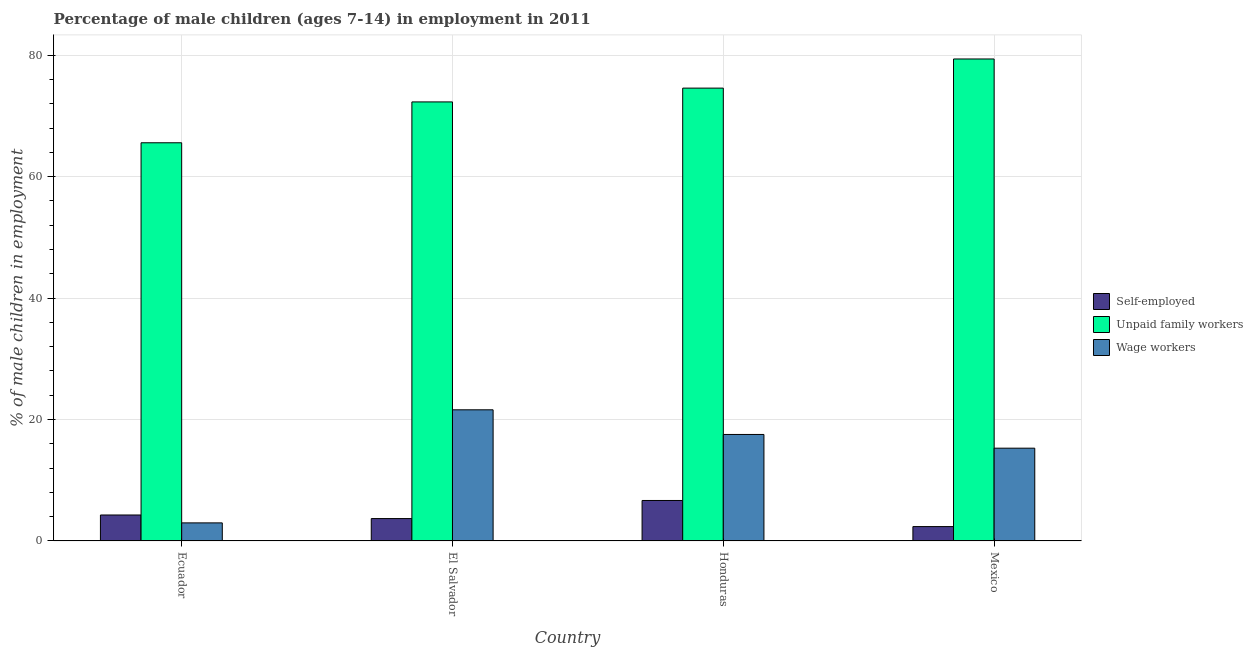How many different coloured bars are there?
Your response must be concise. 3. How many groups of bars are there?
Provide a succinct answer. 4. How many bars are there on the 1st tick from the right?
Ensure brevity in your answer.  3. What is the label of the 2nd group of bars from the left?
Ensure brevity in your answer.  El Salvador. What is the percentage of children employed as unpaid family workers in El Salvador?
Keep it short and to the point. 72.3. Across all countries, what is the maximum percentage of children employed as wage workers?
Your answer should be very brief. 21.6. Across all countries, what is the minimum percentage of children employed as wage workers?
Offer a very short reply. 2.98. What is the total percentage of children employed as unpaid family workers in the graph?
Provide a short and direct response. 291.81. What is the difference between the percentage of self employed children in El Salvador and that in Honduras?
Ensure brevity in your answer.  -2.98. What is the difference between the percentage of children employed as unpaid family workers in Ecuador and the percentage of children employed as wage workers in El Salvador?
Provide a succinct answer. 43.97. What is the average percentage of self employed children per country?
Your answer should be compact. 4.25. What is the difference between the percentage of children employed as wage workers and percentage of children employed as unpaid family workers in Ecuador?
Your answer should be very brief. -62.59. What is the ratio of the percentage of self employed children in El Salvador to that in Honduras?
Provide a succinct answer. 0.55. Is the percentage of children employed as unpaid family workers in Ecuador less than that in Honduras?
Provide a short and direct response. Yes. What is the difference between the highest and the second highest percentage of self employed children?
Ensure brevity in your answer.  2.39. What is the difference between the highest and the lowest percentage of self employed children?
Offer a terse response. 4.3. In how many countries, is the percentage of self employed children greater than the average percentage of self employed children taken over all countries?
Provide a short and direct response. 2. Is the sum of the percentage of children employed as wage workers in Honduras and Mexico greater than the maximum percentage of children employed as unpaid family workers across all countries?
Keep it short and to the point. No. What does the 3rd bar from the left in Mexico represents?
Offer a terse response. Wage workers. What does the 2nd bar from the right in Ecuador represents?
Give a very brief answer. Unpaid family workers. How many countries are there in the graph?
Your answer should be very brief. 4. What is the difference between two consecutive major ticks on the Y-axis?
Offer a very short reply. 20. Are the values on the major ticks of Y-axis written in scientific E-notation?
Offer a very short reply. No. Does the graph contain any zero values?
Make the answer very short. No. Does the graph contain grids?
Your answer should be compact. Yes. How many legend labels are there?
Your response must be concise. 3. How are the legend labels stacked?
Keep it short and to the point. Vertical. What is the title of the graph?
Your answer should be very brief. Percentage of male children (ages 7-14) in employment in 2011. What is the label or title of the Y-axis?
Give a very brief answer. % of male children in employment. What is the % of male children in employment of Self-employed in Ecuador?
Your answer should be very brief. 4.28. What is the % of male children in employment in Unpaid family workers in Ecuador?
Provide a short and direct response. 65.57. What is the % of male children in employment in Wage workers in Ecuador?
Offer a very short reply. 2.98. What is the % of male children in employment of Self-employed in El Salvador?
Your answer should be very brief. 3.69. What is the % of male children in employment of Unpaid family workers in El Salvador?
Your answer should be compact. 72.3. What is the % of male children in employment in Wage workers in El Salvador?
Ensure brevity in your answer.  21.6. What is the % of male children in employment in Self-employed in Honduras?
Ensure brevity in your answer.  6.67. What is the % of male children in employment in Unpaid family workers in Honduras?
Give a very brief answer. 74.57. What is the % of male children in employment in Wage workers in Honduras?
Your response must be concise. 17.54. What is the % of male children in employment of Self-employed in Mexico?
Your response must be concise. 2.37. What is the % of male children in employment in Unpaid family workers in Mexico?
Give a very brief answer. 79.37. What is the % of male children in employment of Wage workers in Mexico?
Make the answer very short. 15.28. Across all countries, what is the maximum % of male children in employment in Self-employed?
Ensure brevity in your answer.  6.67. Across all countries, what is the maximum % of male children in employment in Unpaid family workers?
Your answer should be compact. 79.37. Across all countries, what is the maximum % of male children in employment of Wage workers?
Ensure brevity in your answer.  21.6. Across all countries, what is the minimum % of male children in employment of Self-employed?
Offer a very short reply. 2.37. Across all countries, what is the minimum % of male children in employment of Unpaid family workers?
Your answer should be very brief. 65.57. Across all countries, what is the minimum % of male children in employment in Wage workers?
Your response must be concise. 2.98. What is the total % of male children in employment in Self-employed in the graph?
Keep it short and to the point. 17.01. What is the total % of male children in employment in Unpaid family workers in the graph?
Provide a succinct answer. 291.81. What is the total % of male children in employment in Wage workers in the graph?
Offer a terse response. 57.4. What is the difference between the % of male children in employment of Self-employed in Ecuador and that in El Salvador?
Provide a short and direct response. 0.59. What is the difference between the % of male children in employment of Unpaid family workers in Ecuador and that in El Salvador?
Offer a very short reply. -6.73. What is the difference between the % of male children in employment in Wage workers in Ecuador and that in El Salvador?
Your answer should be compact. -18.62. What is the difference between the % of male children in employment of Self-employed in Ecuador and that in Honduras?
Provide a succinct answer. -2.39. What is the difference between the % of male children in employment in Wage workers in Ecuador and that in Honduras?
Offer a very short reply. -14.56. What is the difference between the % of male children in employment of Self-employed in Ecuador and that in Mexico?
Keep it short and to the point. 1.91. What is the difference between the % of male children in employment in Wage workers in Ecuador and that in Mexico?
Make the answer very short. -12.3. What is the difference between the % of male children in employment of Self-employed in El Salvador and that in Honduras?
Keep it short and to the point. -2.98. What is the difference between the % of male children in employment in Unpaid family workers in El Salvador and that in Honduras?
Provide a succinct answer. -2.27. What is the difference between the % of male children in employment in Wage workers in El Salvador and that in Honduras?
Provide a succinct answer. 4.06. What is the difference between the % of male children in employment in Self-employed in El Salvador and that in Mexico?
Give a very brief answer. 1.32. What is the difference between the % of male children in employment in Unpaid family workers in El Salvador and that in Mexico?
Keep it short and to the point. -7.07. What is the difference between the % of male children in employment in Wage workers in El Salvador and that in Mexico?
Provide a succinct answer. 6.32. What is the difference between the % of male children in employment in Wage workers in Honduras and that in Mexico?
Provide a succinct answer. 2.26. What is the difference between the % of male children in employment of Self-employed in Ecuador and the % of male children in employment of Unpaid family workers in El Salvador?
Make the answer very short. -68.02. What is the difference between the % of male children in employment in Self-employed in Ecuador and the % of male children in employment in Wage workers in El Salvador?
Make the answer very short. -17.32. What is the difference between the % of male children in employment in Unpaid family workers in Ecuador and the % of male children in employment in Wage workers in El Salvador?
Make the answer very short. 43.97. What is the difference between the % of male children in employment in Self-employed in Ecuador and the % of male children in employment in Unpaid family workers in Honduras?
Your answer should be very brief. -70.29. What is the difference between the % of male children in employment in Self-employed in Ecuador and the % of male children in employment in Wage workers in Honduras?
Make the answer very short. -13.26. What is the difference between the % of male children in employment of Unpaid family workers in Ecuador and the % of male children in employment of Wage workers in Honduras?
Ensure brevity in your answer.  48.03. What is the difference between the % of male children in employment in Self-employed in Ecuador and the % of male children in employment in Unpaid family workers in Mexico?
Offer a terse response. -75.09. What is the difference between the % of male children in employment in Self-employed in Ecuador and the % of male children in employment in Wage workers in Mexico?
Offer a terse response. -11. What is the difference between the % of male children in employment in Unpaid family workers in Ecuador and the % of male children in employment in Wage workers in Mexico?
Offer a very short reply. 50.29. What is the difference between the % of male children in employment in Self-employed in El Salvador and the % of male children in employment in Unpaid family workers in Honduras?
Keep it short and to the point. -70.88. What is the difference between the % of male children in employment in Self-employed in El Salvador and the % of male children in employment in Wage workers in Honduras?
Your answer should be compact. -13.85. What is the difference between the % of male children in employment of Unpaid family workers in El Salvador and the % of male children in employment of Wage workers in Honduras?
Keep it short and to the point. 54.76. What is the difference between the % of male children in employment in Self-employed in El Salvador and the % of male children in employment in Unpaid family workers in Mexico?
Your response must be concise. -75.68. What is the difference between the % of male children in employment in Self-employed in El Salvador and the % of male children in employment in Wage workers in Mexico?
Offer a very short reply. -11.59. What is the difference between the % of male children in employment of Unpaid family workers in El Salvador and the % of male children in employment of Wage workers in Mexico?
Make the answer very short. 57.02. What is the difference between the % of male children in employment in Self-employed in Honduras and the % of male children in employment in Unpaid family workers in Mexico?
Provide a short and direct response. -72.7. What is the difference between the % of male children in employment of Self-employed in Honduras and the % of male children in employment of Wage workers in Mexico?
Your answer should be compact. -8.61. What is the difference between the % of male children in employment in Unpaid family workers in Honduras and the % of male children in employment in Wage workers in Mexico?
Offer a very short reply. 59.29. What is the average % of male children in employment in Self-employed per country?
Your response must be concise. 4.25. What is the average % of male children in employment in Unpaid family workers per country?
Ensure brevity in your answer.  72.95. What is the average % of male children in employment of Wage workers per country?
Offer a terse response. 14.35. What is the difference between the % of male children in employment in Self-employed and % of male children in employment in Unpaid family workers in Ecuador?
Provide a short and direct response. -61.29. What is the difference between the % of male children in employment in Self-employed and % of male children in employment in Wage workers in Ecuador?
Make the answer very short. 1.3. What is the difference between the % of male children in employment of Unpaid family workers and % of male children in employment of Wage workers in Ecuador?
Your answer should be very brief. 62.59. What is the difference between the % of male children in employment in Self-employed and % of male children in employment in Unpaid family workers in El Salvador?
Offer a very short reply. -68.61. What is the difference between the % of male children in employment of Self-employed and % of male children in employment of Wage workers in El Salvador?
Ensure brevity in your answer.  -17.91. What is the difference between the % of male children in employment in Unpaid family workers and % of male children in employment in Wage workers in El Salvador?
Offer a very short reply. 50.7. What is the difference between the % of male children in employment of Self-employed and % of male children in employment of Unpaid family workers in Honduras?
Your response must be concise. -67.9. What is the difference between the % of male children in employment of Self-employed and % of male children in employment of Wage workers in Honduras?
Your response must be concise. -10.87. What is the difference between the % of male children in employment of Unpaid family workers and % of male children in employment of Wage workers in Honduras?
Keep it short and to the point. 57.03. What is the difference between the % of male children in employment of Self-employed and % of male children in employment of Unpaid family workers in Mexico?
Offer a very short reply. -77. What is the difference between the % of male children in employment in Self-employed and % of male children in employment in Wage workers in Mexico?
Provide a short and direct response. -12.91. What is the difference between the % of male children in employment of Unpaid family workers and % of male children in employment of Wage workers in Mexico?
Provide a succinct answer. 64.09. What is the ratio of the % of male children in employment in Self-employed in Ecuador to that in El Salvador?
Offer a very short reply. 1.16. What is the ratio of the % of male children in employment in Unpaid family workers in Ecuador to that in El Salvador?
Your answer should be very brief. 0.91. What is the ratio of the % of male children in employment of Wage workers in Ecuador to that in El Salvador?
Provide a succinct answer. 0.14. What is the ratio of the % of male children in employment of Self-employed in Ecuador to that in Honduras?
Your response must be concise. 0.64. What is the ratio of the % of male children in employment of Unpaid family workers in Ecuador to that in Honduras?
Provide a succinct answer. 0.88. What is the ratio of the % of male children in employment in Wage workers in Ecuador to that in Honduras?
Make the answer very short. 0.17. What is the ratio of the % of male children in employment in Self-employed in Ecuador to that in Mexico?
Keep it short and to the point. 1.81. What is the ratio of the % of male children in employment of Unpaid family workers in Ecuador to that in Mexico?
Provide a succinct answer. 0.83. What is the ratio of the % of male children in employment of Wage workers in Ecuador to that in Mexico?
Your answer should be very brief. 0.2. What is the ratio of the % of male children in employment in Self-employed in El Salvador to that in Honduras?
Keep it short and to the point. 0.55. What is the ratio of the % of male children in employment of Unpaid family workers in El Salvador to that in Honduras?
Make the answer very short. 0.97. What is the ratio of the % of male children in employment in Wage workers in El Salvador to that in Honduras?
Your answer should be compact. 1.23. What is the ratio of the % of male children in employment in Self-employed in El Salvador to that in Mexico?
Offer a very short reply. 1.56. What is the ratio of the % of male children in employment of Unpaid family workers in El Salvador to that in Mexico?
Your answer should be compact. 0.91. What is the ratio of the % of male children in employment in Wage workers in El Salvador to that in Mexico?
Offer a terse response. 1.41. What is the ratio of the % of male children in employment in Self-employed in Honduras to that in Mexico?
Provide a succinct answer. 2.81. What is the ratio of the % of male children in employment in Unpaid family workers in Honduras to that in Mexico?
Offer a terse response. 0.94. What is the ratio of the % of male children in employment in Wage workers in Honduras to that in Mexico?
Your answer should be compact. 1.15. What is the difference between the highest and the second highest % of male children in employment of Self-employed?
Offer a very short reply. 2.39. What is the difference between the highest and the second highest % of male children in employment in Wage workers?
Your answer should be compact. 4.06. What is the difference between the highest and the lowest % of male children in employment in Wage workers?
Offer a terse response. 18.62. 